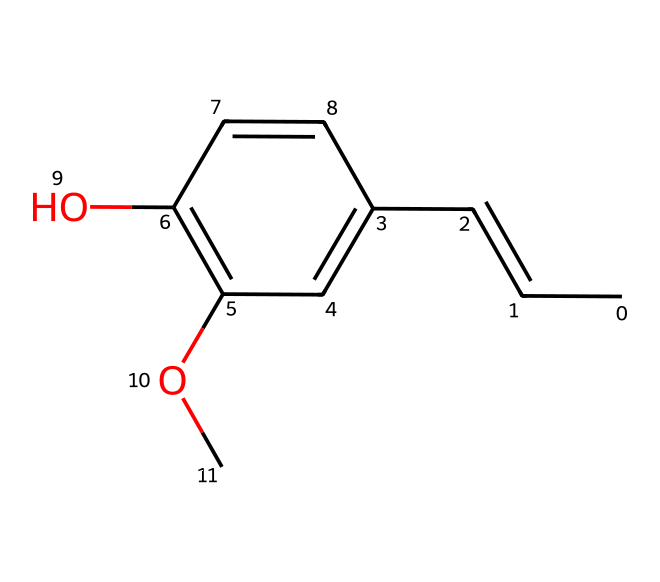how many carbon atoms are in the structure? The SMILES representation can be analyzed to count the number of 'C' characters, which stand for carbon atoms. The structure shows that there are a total of 10 carbon atoms present.
Answer: 10 what functional group is present in the compound? By examining the chemical structure represented in the SMILES, we can identify a hydroxyl group (-OH) due to the presence of the 'O' and its attachment to a carbon atom, indicating that the compound contains a phenolic structure.
Answer: hydroxyl group how many double bonds are in the compound? The SMILES representation reveals that there are multiple 'C=C' segments in the structure. Counting these occurrences shows that there are two double bonds present.
Answer: 2 does this compound contain any oxygen atoms? By reviewing the SMILES, we can identify the presence of 'O' in the structure. There are two oxygen atoms indicated in the entire molecule, confirming their presence.
Answer: 2 is this compound a type of coordination compound? Coordination compounds typically involve a central metal atom complexed with ligands. Analyzing the structure reveals no metal atom or coordination behavior, indicating that this compound does not qualify as a coordination compound.
Answer: no what type of molecular geometry could this compound have? Given the lack of central metal and the structure shown in the SMILES, the compound's geometry can be deduced from the arrangement of its carbon rings and hydroxyl group, primarily adopting a planar configuration.
Answer: planar 